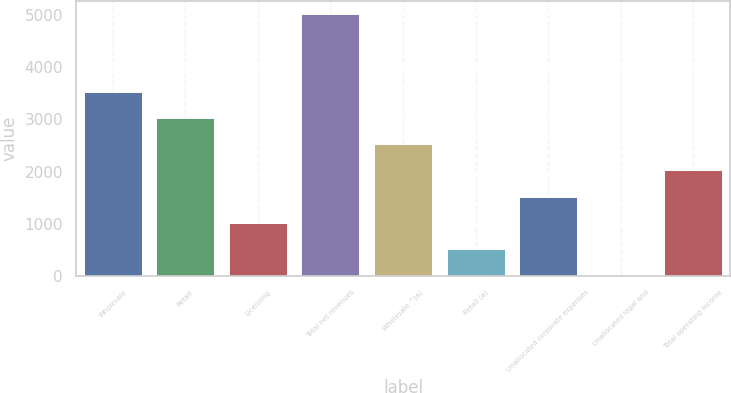<chart> <loc_0><loc_0><loc_500><loc_500><bar_chart><fcel>Wholesale<fcel>Retail<fcel>Licensing<fcel>Total net revenues<fcel>Wholesale ^(a)<fcel>Retail (a)<fcel>Unallocated corporate expenses<fcel>Unallocated legal and<fcel>Total operating income<nl><fcel>3520.16<fcel>3020.58<fcel>1022.26<fcel>5018.9<fcel>2521<fcel>522.68<fcel>1521.84<fcel>23.1<fcel>2021.42<nl></chart> 